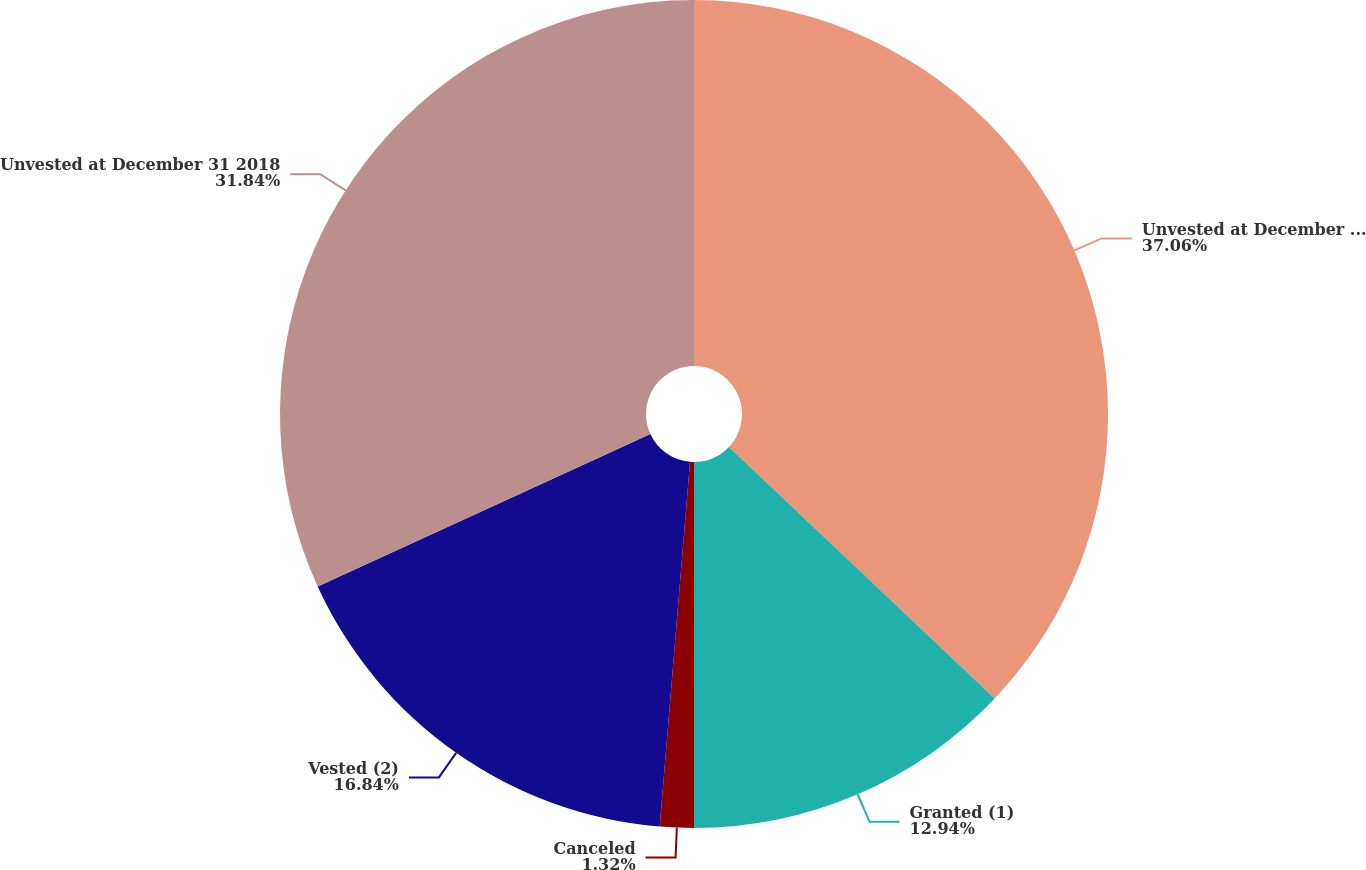Convert chart. <chart><loc_0><loc_0><loc_500><loc_500><pie_chart><fcel>Unvested at December 31 2017<fcel>Granted (1)<fcel>Canceled<fcel>Vested (2)<fcel>Unvested at December 31 2018<nl><fcel>37.06%<fcel>12.94%<fcel>1.32%<fcel>16.84%<fcel>31.84%<nl></chart> 